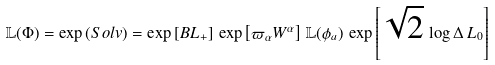<formula> <loc_0><loc_0><loc_500><loc_500>\mathbb { L } ( \Phi ) = \exp \left ( S o l v \right ) = \exp \left [ { B L _ { + } } \right ] \, \exp \left [ { \varpi _ { \alpha } W ^ { \alpha } } \right ] \, \mathbb { L } ( \phi _ { a } ) \, \exp \left [ \sqrt { 2 } \, \log \Delta \, L _ { 0 } \right ]</formula> 